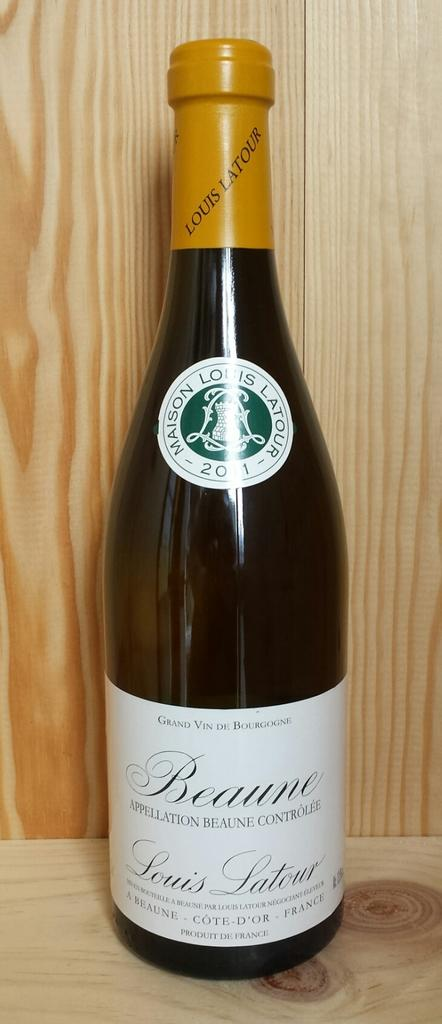<image>
Offer a succinct explanation of the picture presented. A 2011 bottle of Maison Lous Latour Beaune 